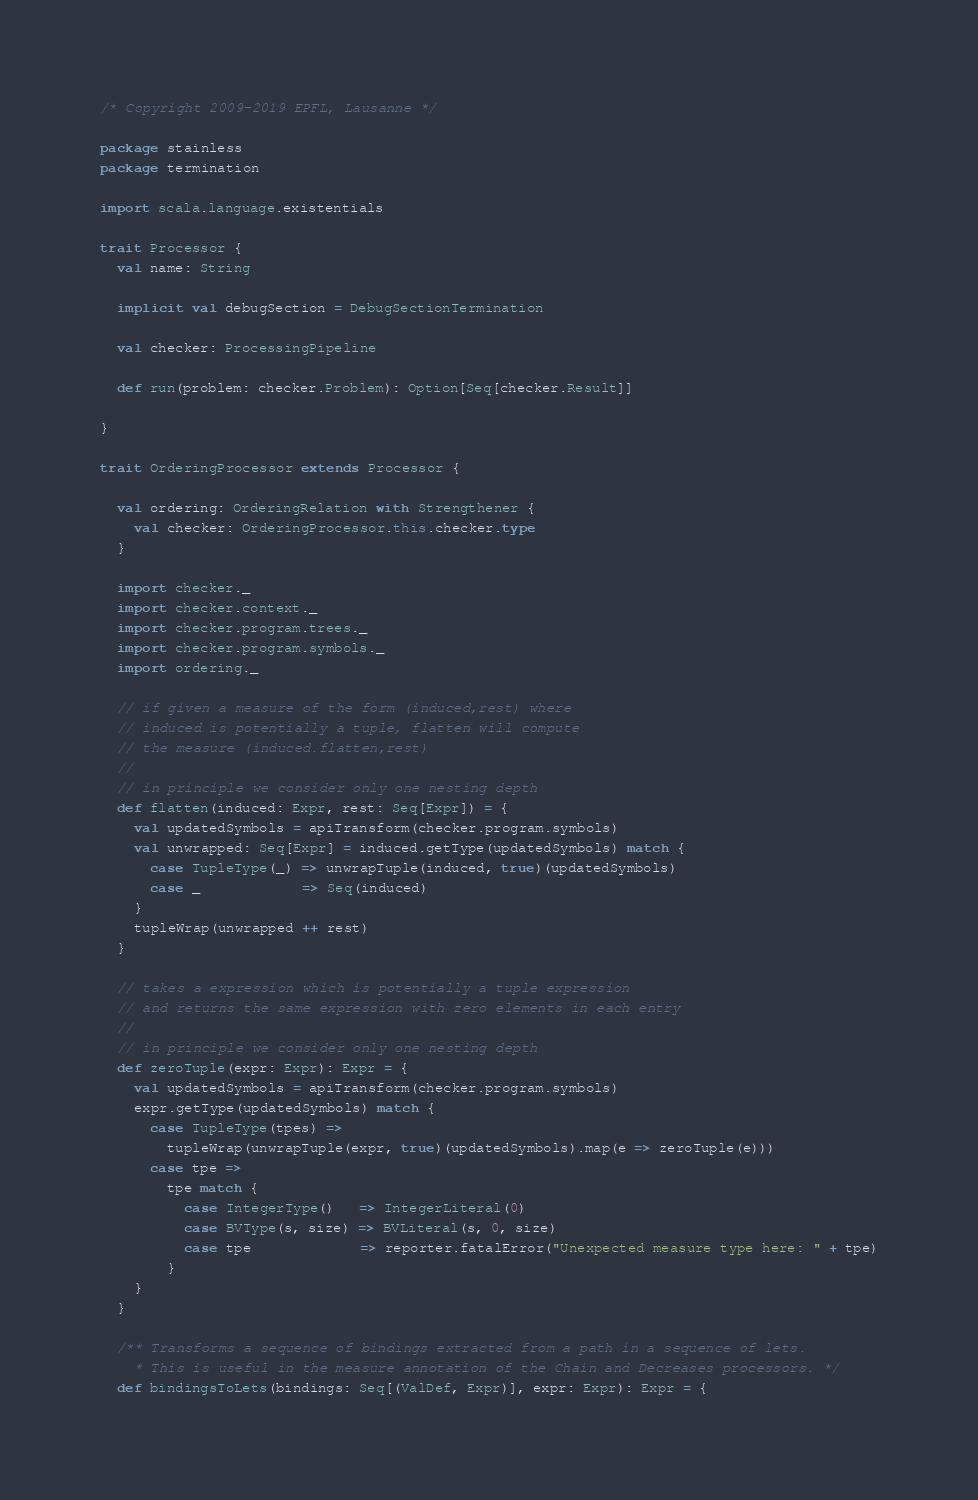Convert code to text. <code><loc_0><loc_0><loc_500><loc_500><_Scala_>/* Copyright 2009-2019 EPFL, Lausanne */

package stainless
package termination

import scala.language.existentials

trait Processor {
  val name: String

  implicit val debugSection = DebugSectionTermination

  val checker: ProcessingPipeline

  def run(problem: checker.Problem): Option[Seq[checker.Result]]

}

trait OrderingProcessor extends Processor {

  val ordering: OrderingRelation with Strengthener {
    val checker: OrderingProcessor.this.checker.type
  }

  import checker._
  import checker.context._
  import checker.program.trees._
  import checker.program.symbols._
  import ordering._

  // if given a measure of the form (induced,rest) where
  // induced is potentially a tuple, flatten will compute
  // the measure (induced.flatten,rest)
  //
  // in principle we consider only one nesting depth
  def flatten(induced: Expr, rest: Seq[Expr]) = {
    val updatedSymbols = apiTransform(checker.program.symbols)
    val unwrapped: Seq[Expr] = induced.getType(updatedSymbols) match {
      case TupleType(_) => unwrapTuple(induced, true)(updatedSymbols)
      case _            => Seq(induced)
    }
    tupleWrap(unwrapped ++ rest)
  }

  // takes a expression which is potentially a tuple expression
  // and returns the same expression with zero elements in each entry
  //
  // in principle we consider only one nesting depth
  def zeroTuple(expr: Expr): Expr = {
    val updatedSymbols = apiTransform(checker.program.symbols)
    expr.getType(updatedSymbols) match {
      case TupleType(tpes) =>
        tupleWrap(unwrapTuple(expr, true)(updatedSymbols).map(e => zeroTuple(e)))
      case tpe =>
        tpe match {
          case IntegerType()   => IntegerLiteral(0)
          case BVType(s, size) => BVLiteral(s, 0, size)
          case tpe             => reporter.fatalError("Unexpected measure type here: " + tpe)
        }
    }
  }

  /** Transforms a sequence of bindings extracted from a path in a sequence of lets.
    * This is useful in the measure annotation of the Chain and Decreases processors. */
  def bindingsToLets(bindings: Seq[(ValDef, Expr)], expr: Expr): Expr = {</code> 